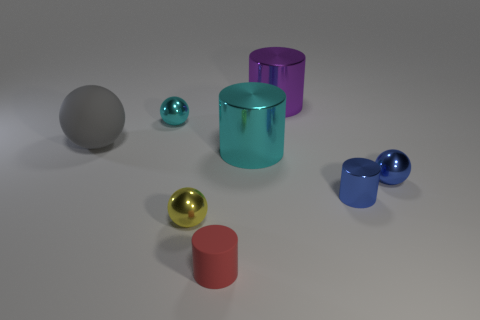There is a tiny metal thing that is the same color as the small metal cylinder; what is its shape?
Provide a short and direct response. Sphere. What is the cyan object left of the big cylinder that is in front of the tiny sphere on the left side of the yellow metal object made of?
Give a very brief answer. Metal. There is a shiny thing behind the cyan shiny thing left of the yellow object; what is its color?
Give a very brief answer. Purple. There is a shiny cylinder that is the same size as the yellow metallic sphere; what is its color?
Keep it short and to the point. Blue. What number of small things are purple shiny objects or balls?
Your answer should be very brief. 3. Is the number of cylinders behind the large sphere greater than the number of big cylinders left of the red cylinder?
Offer a terse response. Yes. There is a metallic sphere that is the same color as the tiny metallic cylinder; what size is it?
Provide a succinct answer. Small. How many other objects are there of the same size as the gray rubber thing?
Your response must be concise. 2. Is the material of the cylinder behind the gray matte thing the same as the cyan cylinder?
Your response must be concise. Yes. What number of other things are there of the same color as the big rubber sphere?
Give a very brief answer. 0. 